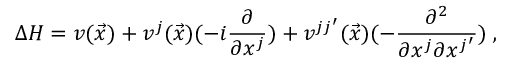Convert formula to latex. <formula><loc_0><loc_0><loc_500><loc_500>\Delta H = v ( \vec { x } ) + v ^ { j } ( \vec { x } ) ( - i \frac { \partial } { \partial x ^ { j } } ) + v ^ { j j ^ { \prime } } ( \vec { x } ) ( - \frac { \partial ^ { 2 } } { \partial x ^ { j } \partial x ^ { j ^ { \prime } } } ) \, ,</formula> 